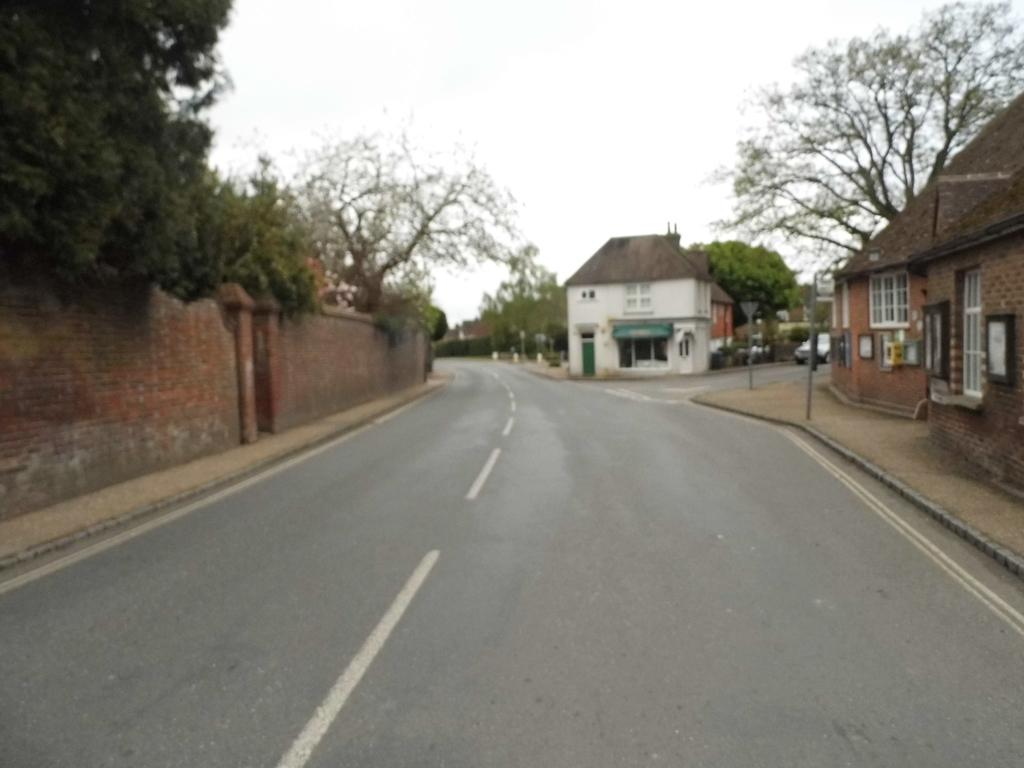What type of pathway is visible in the image? There is a road in the image. What structure can be seen surrounding the area in the image? There is a compound wall in the image. What type of vegetation is present in the image? There are plants and trees in the image. What architectural features can be seen in the image? There are poles and buildings in the image. What mode of transportation is visible in the image? There is a car in the image. What part of the natural environment is visible in the image? The sky is visible in the image. Can you see a kitty baking a cake in the image? There is no kitty or cake present in the image. Is it possible to touch the sky in the image? The sky is visible in the image, but it is not physically present in the scene, so it cannot be touched. 